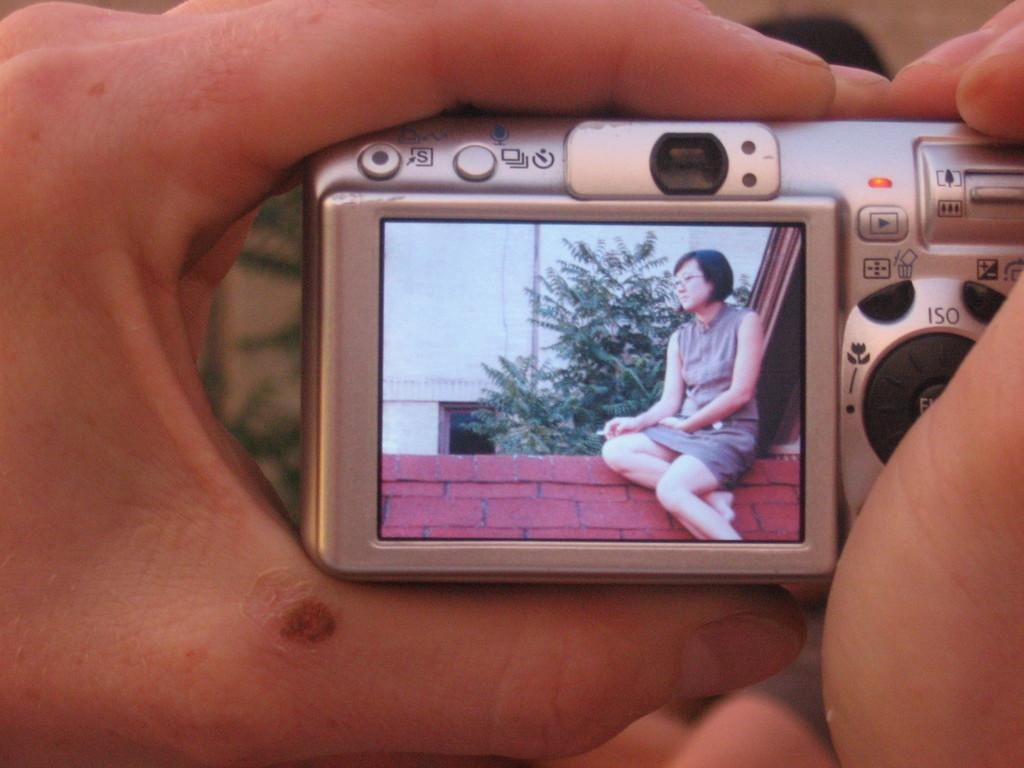Provide a one-sentence caption for the provided image. One of the buttons on the camera is for changing the ISO setting. 